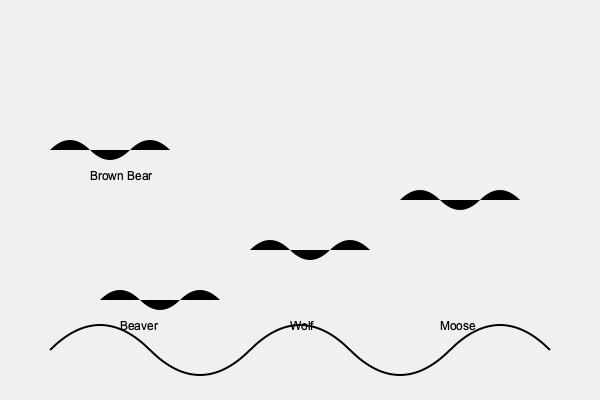Based on the silhouettes of Alaskan wildlife shown above, arrange these animals in order from smallest to largest: beaver, wolf, moose, and brown bear. Which animal would Buzzy Peltola likely encounter most frequently in his conservation work? To answer this question, we need to consider the relative sizes of these Alaskan animals and their habitats:

1. Beaver: Average length 3-4 feet, weight 35-65 pounds
2. Wolf: Average length 4-6.5 feet, weight 70-150 pounds
3. Moose: Average length 8-10 feet, weight 800-1,600 pounds
4. Brown Bear: Average length 6.5-9 feet, weight 700-1,400 pounds

Arranging from smallest to largest:
Beaver < Wolf < Brown Bear < Moose

Regarding Buzzy Peltola's work:
Buzzy Peltola is known for his conservation efforts in Alaska, particularly with the Alaska Department of Fish and Game. While he would likely encounter all of these animals in his work, the most frequent encounters would probably be with wolves. This is because:

1. Wolves are more widespread across Alaska than moose or brown bears.
2. Wolf management is a significant part of wildlife conservation in Alaska due to their impact on prey populations.
3. Beavers, while common, are less frequently the focus of large-scale conservation efforts compared to wolves.

Therefore, in his conservation work, Buzzy Peltola would likely encounter wolves most frequently among these four animals.
Answer: Beaver < Wolf < Brown Bear < Moose; Wolves 